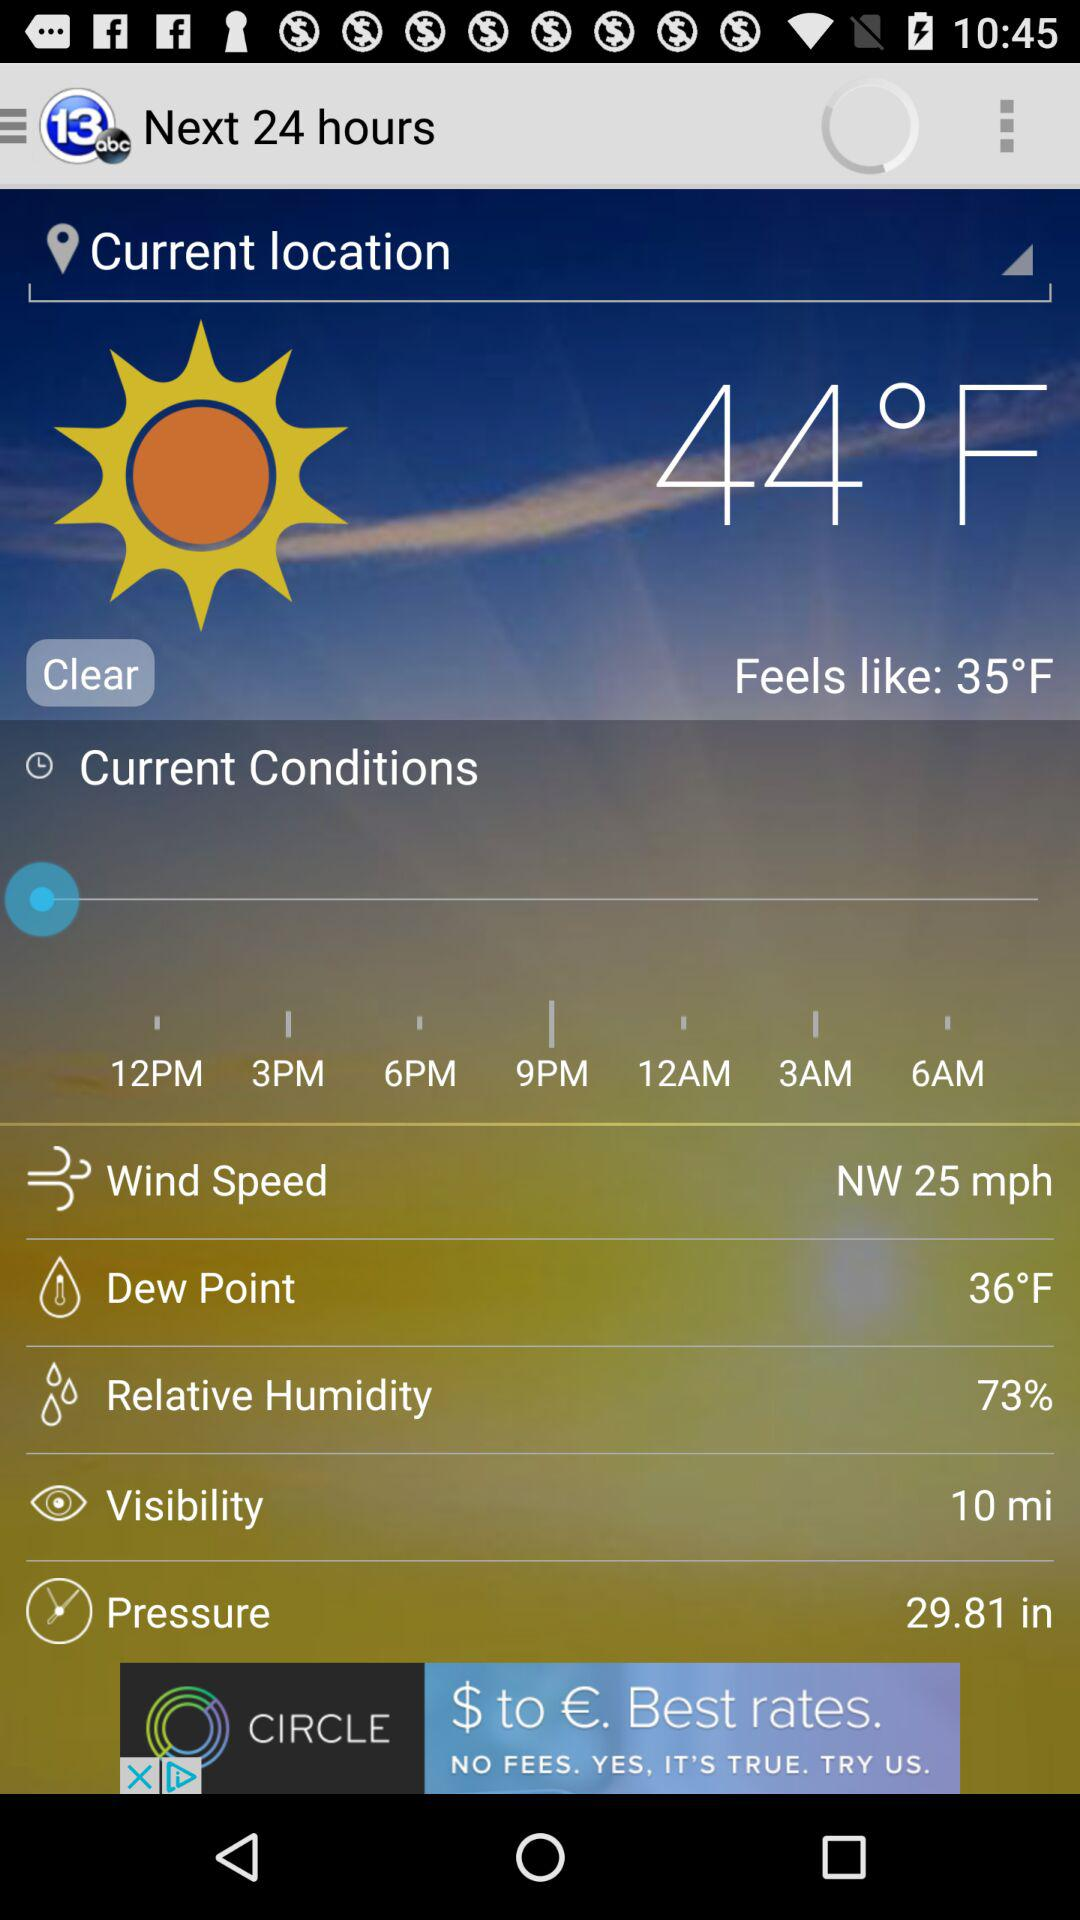How much warmer is the current temperature than the feels like temperature?
Answer the question using a single word or phrase. 9°F 